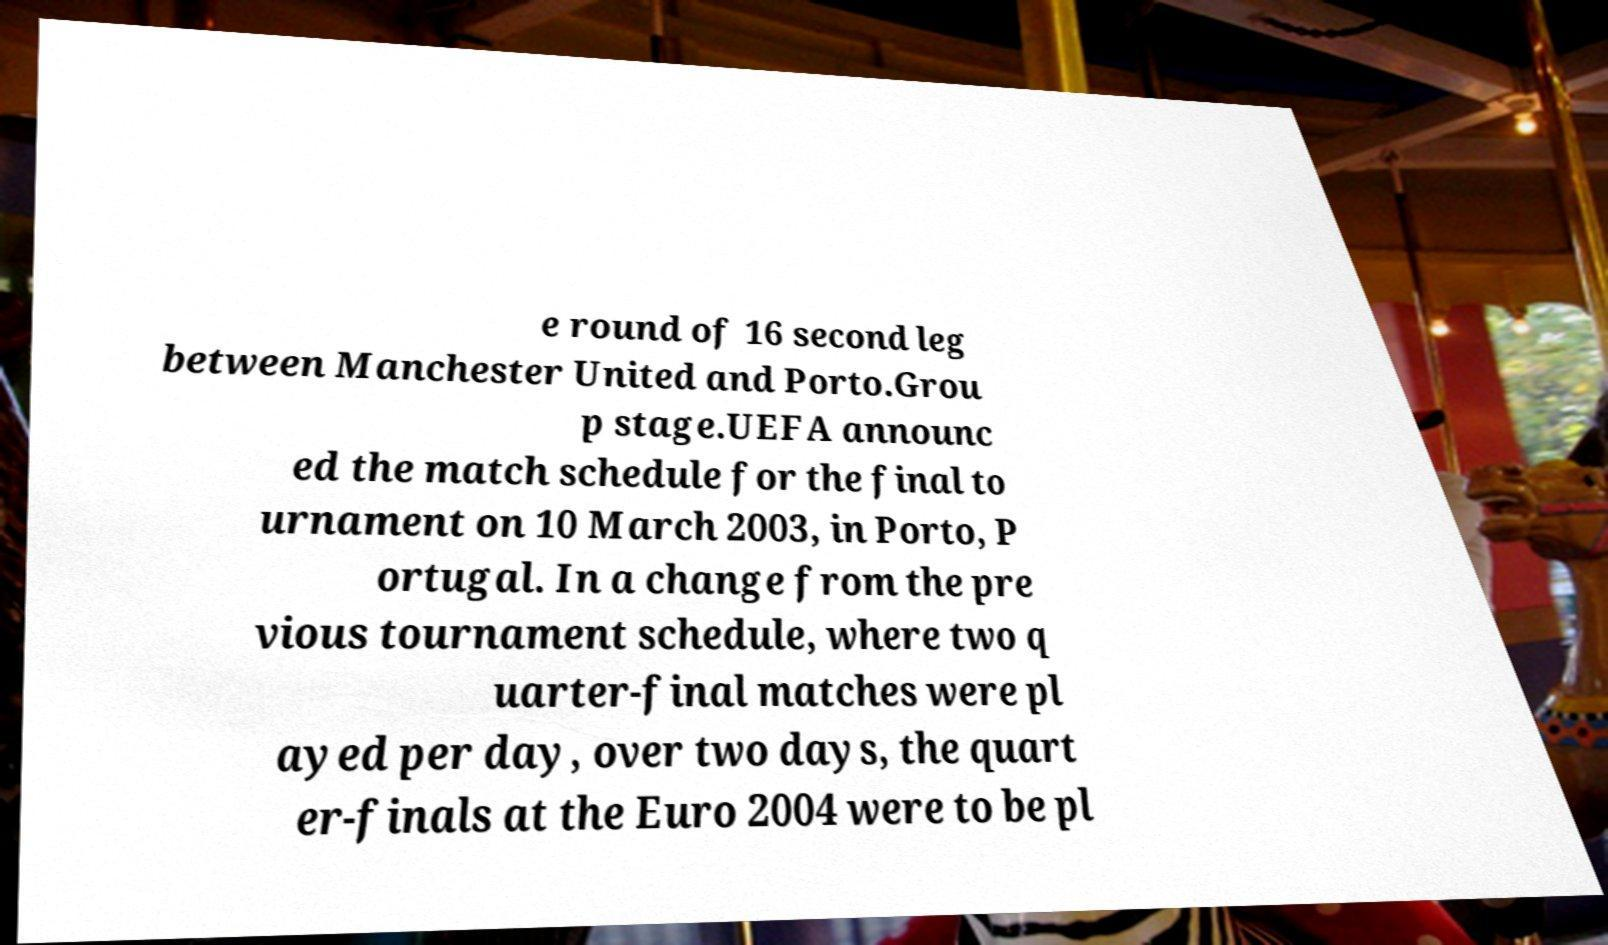There's text embedded in this image that I need extracted. Can you transcribe it verbatim? e round of 16 second leg between Manchester United and Porto.Grou p stage.UEFA announc ed the match schedule for the final to urnament on 10 March 2003, in Porto, P ortugal. In a change from the pre vious tournament schedule, where two q uarter-final matches were pl ayed per day, over two days, the quart er-finals at the Euro 2004 were to be pl 